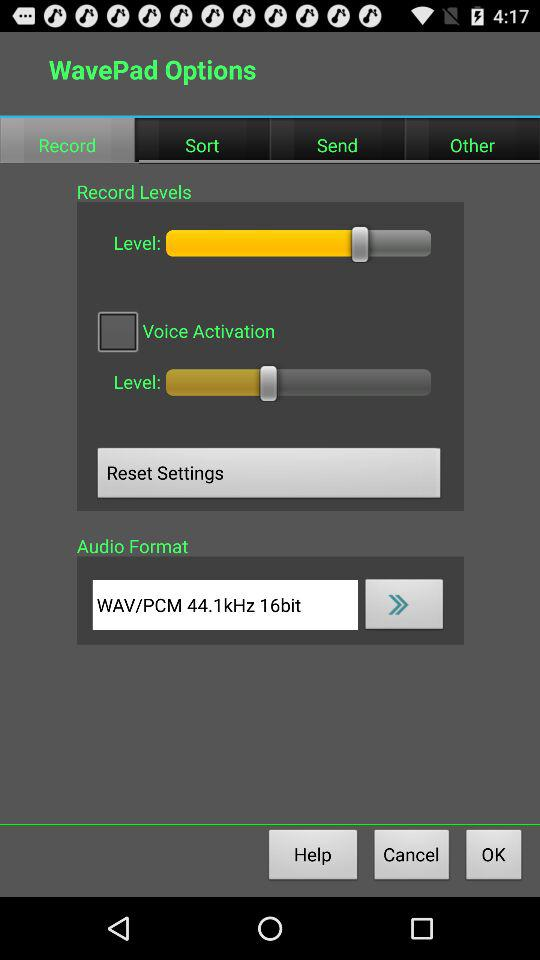What's the audio format? The audio format is WAV/PCM. 